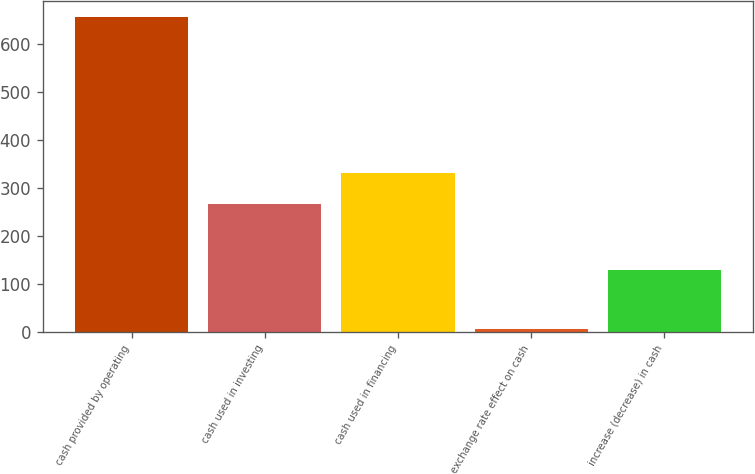<chart> <loc_0><loc_0><loc_500><loc_500><bar_chart><fcel>cash provided by operating<fcel>cash used in investing<fcel>cash used in financing<fcel>exchange rate effect on cash<fcel>increase (decrease) in cash<nl><fcel>655.3<fcel>265.6<fcel>330.6<fcel>5.3<fcel>128.2<nl></chart> 